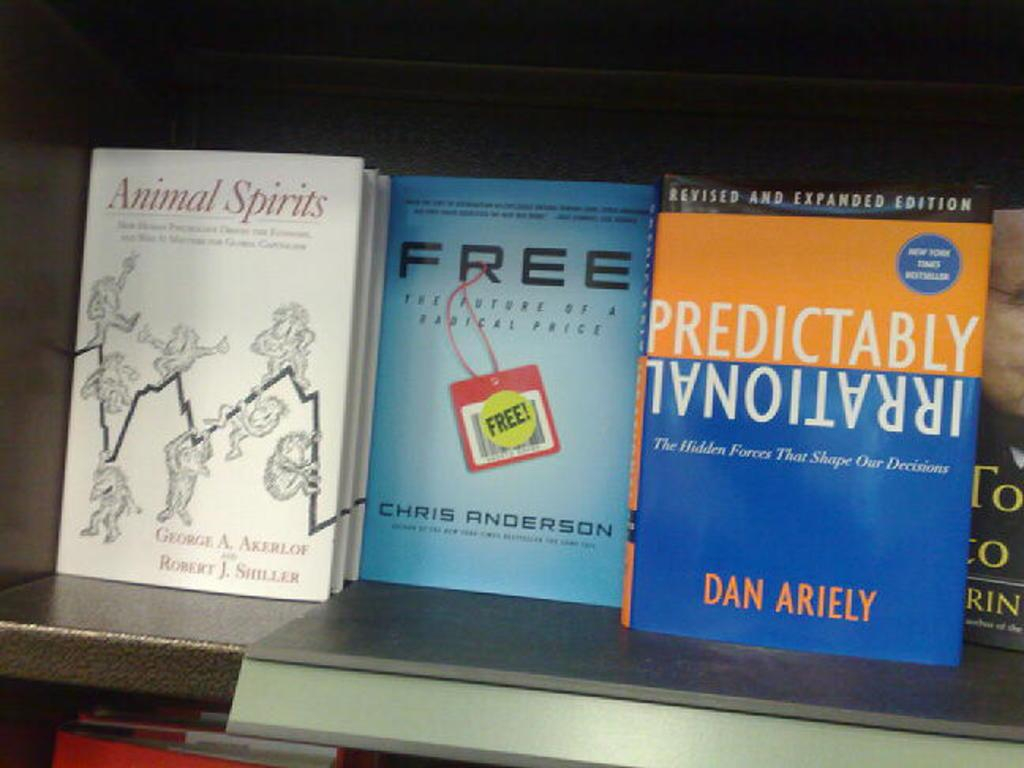<image>
Present a compact description of the photo's key features. A shelf with several books titles including on titles Free. 